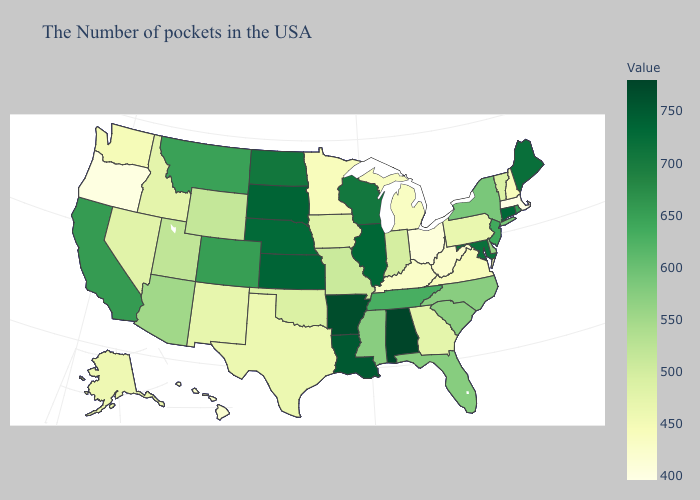Does the map have missing data?
Answer briefly. No. Does Indiana have the highest value in the USA?
Keep it brief. No. Which states have the lowest value in the MidWest?
Quick response, please. Ohio. Which states have the lowest value in the West?
Give a very brief answer. Oregon. 